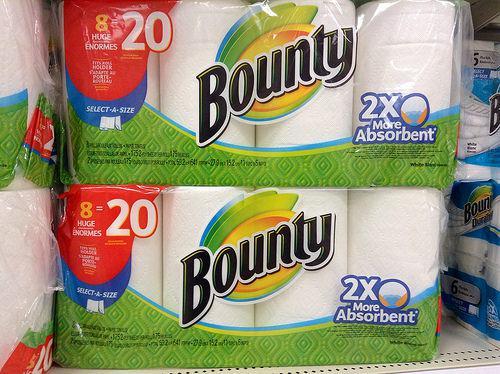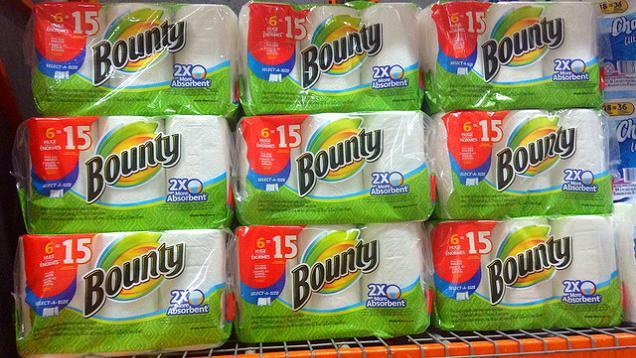The first image is the image on the left, the second image is the image on the right. Given the left and right images, does the statement "The left-hand image shows exactly one multi-pack of paper towels." hold true? Answer yes or no. No. The first image is the image on the left, the second image is the image on the right. Considering the images on both sides, is "A single package of paper towels stands alone in the image on the left." valid? Answer yes or no. No. 